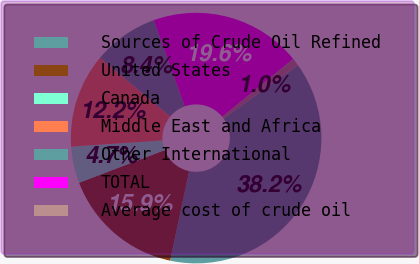Convert chart. <chart><loc_0><loc_0><loc_500><loc_500><pie_chart><fcel>Sources of Crude Oil Refined<fcel>United States<fcel>Canada<fcel>Middle East and Africa<fcel>Other International<fcel>TOTAL<fcel>Average cost of crude oil<nl><fcel>38.22%<fcel>15.88%<fcel>4.71%<fcel>12.16%<fcel>8.44%<fcel>19.6%<fcel>0.99%<nl></chart> 